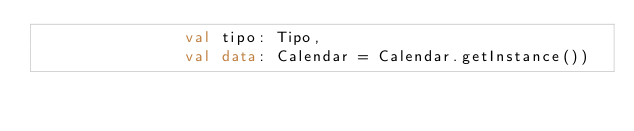<code> <loc_0><loc_0><loc_500><loc_500><_Kotlin_>                val tipo: Tipo,
                val data: Calendar = Calendar.getInstance())</code> 